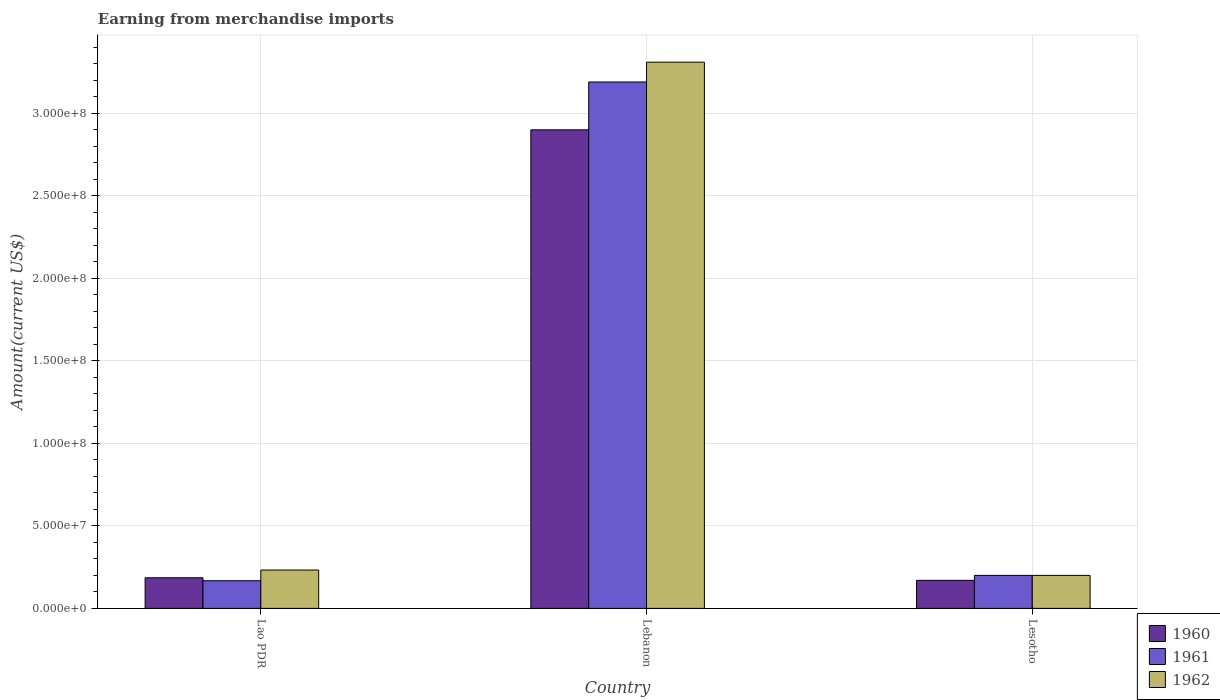Are the number of bars per tick equal to the number of legend labels?
Ensure brevity in your answer.  Yes. Are the number of bars on each tick of the X-axis equal?
Your answer should be compact. Yes. How many bars are there on the 2nd tick from the right?
Keep it short and to the point. 3. What is the label of the 2nd group of bars from the left?
Ensure brevity in your answer.  Lebanon. In how many cases, is the number of bars for a given country not equal to the number of legend labels?
Offer a terse response. 0. What is the amount earned from merchandise imports in 1960 in Lebanon?
Your response must be concise. 2.90e+08. Across all countries, what is the maximum amount earned from merchandise imports in 1960?
Your response must be concise. 2.90e+08. Across all countries, what is the minimum amount earned from merchandise imports in 1960?
Offer a terse response. 1.70e+07. In which country was the amount earned from merchandise imports in 1961 maximum?
Give a very brief answer. Lebanon. In which country was the amount earned from merchandise imports in 1962 minimum?
Offer a very short reply. Lesotho. What is the total amount earned from merchandise imports in 1962 in the graph?
Your response must be concise. 3.74e+08. What is the difference between the amount earned from merchandise imports in 1962 in Lao PDR and that in Lesotho?
Make the answer very short. 3.25e+06. What is the difference between the amount earned from merchandise imports in 1962 in Lesotho and the amount earned from merchandise imports in 1961 in Lao PDR?
Give a very brief answer. 3.25e+06. What is the average amount earned from merchandise imports in 1960 per country?
Offer a very short reply. 1.09e+08. What is the ratio of the amount earned from merchandise imports in 1960 in Lao PDR to that in Lesotho?
Provide a short and direct response. 1.09. What is the difference between the highest and the second highest amount earned from merchandise imports in 1961?
Offer a terse response. 2.99e+08. What is the difference between the highest and the lowest amount earned from merchandise imports in 1961?
Your answer should be very brief. 3.02e+08. In how many countries, is the amount earned from merchandise imports in 1961 greater than the average amount earned from merchandise imports in 1961 taken over all countries?
Ensure brevity in your answer.  1. Is the sum of the amount earned from merchandise imports in 1961 in Lao PDR and Lesotho greater than the maximum amount earned from merchandise imports in 1960 across all countries?
Make the answer very short. No. What does the 1st bar from the right in Lao PDR represents?
Make the answer very short. 1962. How many bars are there?
Keep it short and to the point. 9. Are the values on the major ticks of Y-axis written in scientific E-notation?
Your answer should be compact. Yes. Does the graph contain any zero values?
Make the answer very short. No. Where does the legend appear in the graph?
Keep it short and to the point. Bottom right. How are the legend labels stacked?
Keep it short and to the point. Vertical. What is the title of the graph?
Offer a very short reply. Earning from merchandise imports. What is the label or title of the Y-axis?
Your response must be concise. Amount(current US$). What is the Amount(current US$) of 1960 in Lao PDR?
Ensure brevity in your answer.  1.86e+07. What is the Amount(current US$) of 1961 in Lao PDR?
Your answer should be compact. 1.68e+07. What is the Amount(current US$) of 1962 in Lao PDR?
Keep it short and to the point. 2.32e+07. What is the Amount(current US$) in 1960 in Lebanon?
Offer a very short reply. 2.90e+08. What is the Amount(current US$) of 1961 in Lebanon?
Offer a very short reply. 3.19e+08. What is the Amount(current US$) in 1962 in Lebanon?
Give a very brief answer. 3.31e+08. What is the Amount(current US$) of 1960 in Lesotho?
Provide a short and direct response. 1.70e+07. What is the Amount(current US$) in 1961 in Lesotho?
Your answer should be very brief. 2.00e+07. Across all countries, what is the maximum Amount(current US$) of 1960?
Your answer should be very brief. 2.90e+08. Across all countries, what is the maximum Amount(current US$) in 1961?
Offer a very short reply. 3.19e+08. Across all countries, what is the maximum Amount(current US$) of 1962?
Provide a succinct answer. 3.31e+08. Across all countries, what is the minimum Amount(current US$) of 1960?
Ensure brevity in your answer.  1.70e+07. Across all countries, what is the minimum Amount(current US$) of 1961?
Ensure brevity in your answer.  1.68e+07. Across all countries, what is the minimum Amount(current US$) of 1962?
Provide a succinct answer. 2.00e+07. What is the total Amount(current US$) of 1960 in the graph?
Make the answer very short. 3.26e+08. What is the total Amount(current US$) of 1961 in the graph?
Your answer should be very brief. 3.56e+08. What is the total Amount(current US$) in 1962 in the graph?
Ensure brevity in your answer.  3.74e+08. What is the difference between the Amount(current US$) of 1960 in Lao PDR and that in Lebanon?
Ensure brevity in your answer.  -2.71e+08. What is the difference between the Amount(current US$) in 1961 in Lao PDR and that in Lebanon?
Your response must be concise. -3.02e+08. What is the difference between the Amount(current US$) of 1962 in Lao PDR and that in Lebanon?
Make the answer very short. -3.08e+08. What is the difference between the Amount(current US$) of 1960 in Lao PDR and that in Lesotho?
Offer a terse response. 1.55e+06. What is the difference between the Amount(current US$) of 1961 in Lao PDR and that in Lesotho?
Offer a very short reply. -3.25e+06. What is the difference between the Amount(current US$) of 1962 in Lao PDR and that in Lesotho?
Your response must be concise. 3.25e+06. What is the difference between the Amount(current US$) of 1960 in Lebanon and that in Lesotho?
Give a very brief answer. 2.73e+08. What is the difference between the Amount(current US$) in 1961 in Lebanon and that in Lesotho?
Keep it short and to the point. 2.99e+08. What is the difference between the Amount(current US$) in 1962 in Lebanon and that in Lesotho?
Ensure brevity in your answer.  3.11e+08. What is the difference between the Amount(current US$) in 1960 in Lao PDR and the Amount(current US$) in 1961 in Lebanon?
Give a very brief answer. -3.00e+08. What is the difference between the Amount(current US$) in 1960 in Lao PDR and the Amount(current US$) in 1962 in Lebanon?
Ensure brevity in your answer.  -3.12e+08. What is the difference between the Amount(current US$) in 1961 in Lao PDR and the Amount(current US$) in 1962 in Lebanon?
Your answer should be compact. -3.14e+08. What is the difference between the Amount(current US$) of 1960 in Lao PDR and the Amount(current US$) of 1961 in Lesotho?
Provide a short and direct response. -1.45e+06. What is the difference between the Amount(current US$) in 1960 in Lao PDR and the Amount(current US$) in 1962 in Lesotho?
Ensure brevity in your answer.  -1.45e+06. What is the difference between the Amount(current US$) in 1961 in Lao PDR and the Amount(current US$) in 1962 in Lesotho?
Make the answer very short. -3.25e+06. What is the difference between the Amount(current US$) in 1960 in Lebanon and the Amount(current US$) in 1961 in Lesotho?
Ensure brevity in your answer.  2.70e+08. What is the difference between the Amount(current US$) in 1960 in Lebanon and the Amount(current US$) in 1962 in Lesotho?
Provide a short and direct response. 2.70e+08. What is the difference between the Amount(current US$) of 1961 in Lebanon and the Amount(current US$) of 1962 in Lesotho?
Offer a terse response. 2.99e+08. What is the average Amount(current US$) of 1960 per country?
Ensure brevity in your answer.  1.09e+08. What is the average Amount(current US$) in 1961 per country?
Ensure brevity in your answer.  1.19e+08. What is the average Amount(current US$) in 1962 per country?
Your answer should be very brief. 1.25e+08. What is the difference between the Amount(current US$) of 1960 and Amount(current US$) of 1961 in Lao PDR?
Your response must be concise. 1.80e+06. What is the difference between the Amount(current US$) of 1960 and Amount(current US$) of 1962 in Lao PDR?
Ensure brevity in your answer.  -4.70e+06. What is the difference between the Amount(current US$) in 1961 and Amount(current US$) in 1962 in Lao PDR?
Your answer should be very brief. -6.50e+06. What is the difference between the Amount(current US$) in 1960 and Amount(current US$) in 1961 in Lebanon?
Your answer should be very brief. -2.90e+07. What is the difference between the Amount(current US$) of 1960 and Amount(current US$) of 1962 in Lebanon?
Make the answer very short. -4.10e+07. What is the difference between the Amount(current US$) of 1961 and Amount(current US$) of 1962 in Lebanon?
Your response must be concise. -1.20e+07. What is the difference between the Amount(current US$) of 1960 and Amount(current US$) of 1961 in Lesotho?
Offer a very short reply. -3.00e+06. What is the difference between the Amount(current US$) of 1960 and Amount(current US$) of 1962 in Lesotho?
Your response must be concise. -3.00e+06. What is the ratio of the Amount(current US$) in 1960 in Lao PDR to that in Lebanon?
Your answer should be very brief. 0.06. What is the ratio of the Amount(current US$) in 1961 in Lao PDR to that in Lebanon?
Offer a very short reply. 0.05. What is the ratio of the Amount(current US$) in 1962 in Lao PDR to that in Lebanon?
Your answer should be compact. 0.07. What is the ratio of the Amount(current US$) in 1960 in Lao PDR to that in Lesotho?
Your answer should be compact. 1.09. What is the ratio of the Amount(current US$) of 1961 in Lao PDR to that in Lesotho?
Your response must be concise. 0.84. What is the ratio of the Amount(current US$) of 1962 in Lao PDR to that in Lesotho?
Make the answer very short. 1.16. What is the ratio of the Amount(current US$) of 1960 in Lebanon to that in Lesotho?
Your response must be concise. 17.06. What is the ratio of the Amount(current US$) of 1961 in Lebanon to that in Lesotho?
Your answer should be compact. 15.95. What is the ratio of the Amount(current US$) of 1962 in Lebanon to that in Lesotho?
Give a very brief answer. 16.55. What is the difference between the highest and the second highest Amount(current US$) in 1960?
Make the answer very short. 2.71e+08. What is the difference between the highest and the second highest Amount(current US$) in 1961?
Make the answer very short. 2.99e+08. What is the difference between the highest and the second highest Amount(current US$) of 1962?
Your response must be concise. 3.08e+08. What is the difference between the highest and the lowest Amount(current US$) of 1960?
Ensure brevity in your answer.  2.73e+08. What is the difference between the highest and the lowest Amount(current US$) of 1961?
Make the answer very short. 3.02e+08. What is the difference between the highest and the lowest Amount(current US$) of 1962?
Offer a terse response. 3.11e+08. 